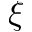<formula> <loc_0><loc_0><loc_500><loc_500>\xi</formula> 